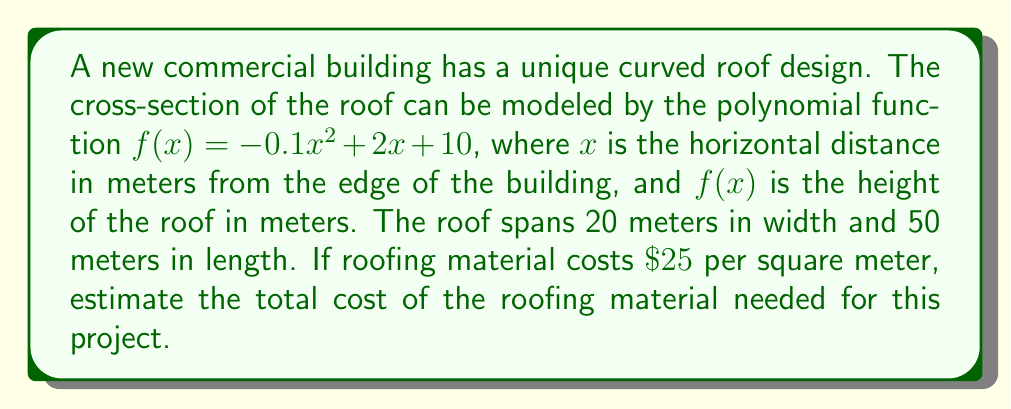Could you help me with this problem? To solve this problem, we need to follow these steps:

1) First, we need to find the area of the curved cross-section. This can be done by integrating the function $f(x)$ from 0 to 20:

   $$A = \int_0^{20} f(x) dx = \int_0^{20} (-0.1x^2 + 2x + 10) dx$$

2) Integrating this function:

   $$A = [-\frac{1}{30}x^3 + x^2 + 10x]_0^{20}$$
   $$A = [-\frac{1}{30}(20^3) + (20^2) + 10(20)] - [0]$$
   $$A = [-266.67 + 400 + 200] = 333.33 \text{ m}^2$$

3) This area represents the cross-section. To get the total surface area of the roof, we need to multiply this by the length of the building:

   $$\text{Total Area} = 333.33 \times 50 = 16,666.5 \text{ m}^2$$

4) Now that we have the total area, we can calculate the cost by multiplying by the price per square meter:

   $$\text{Total Cost} = 16,666.5 \times \$25 = \$416,662.50$$

Therefore, the estimated cost of the roofing material is $\$416,662.50$.
Answer: $\$416,662.50 